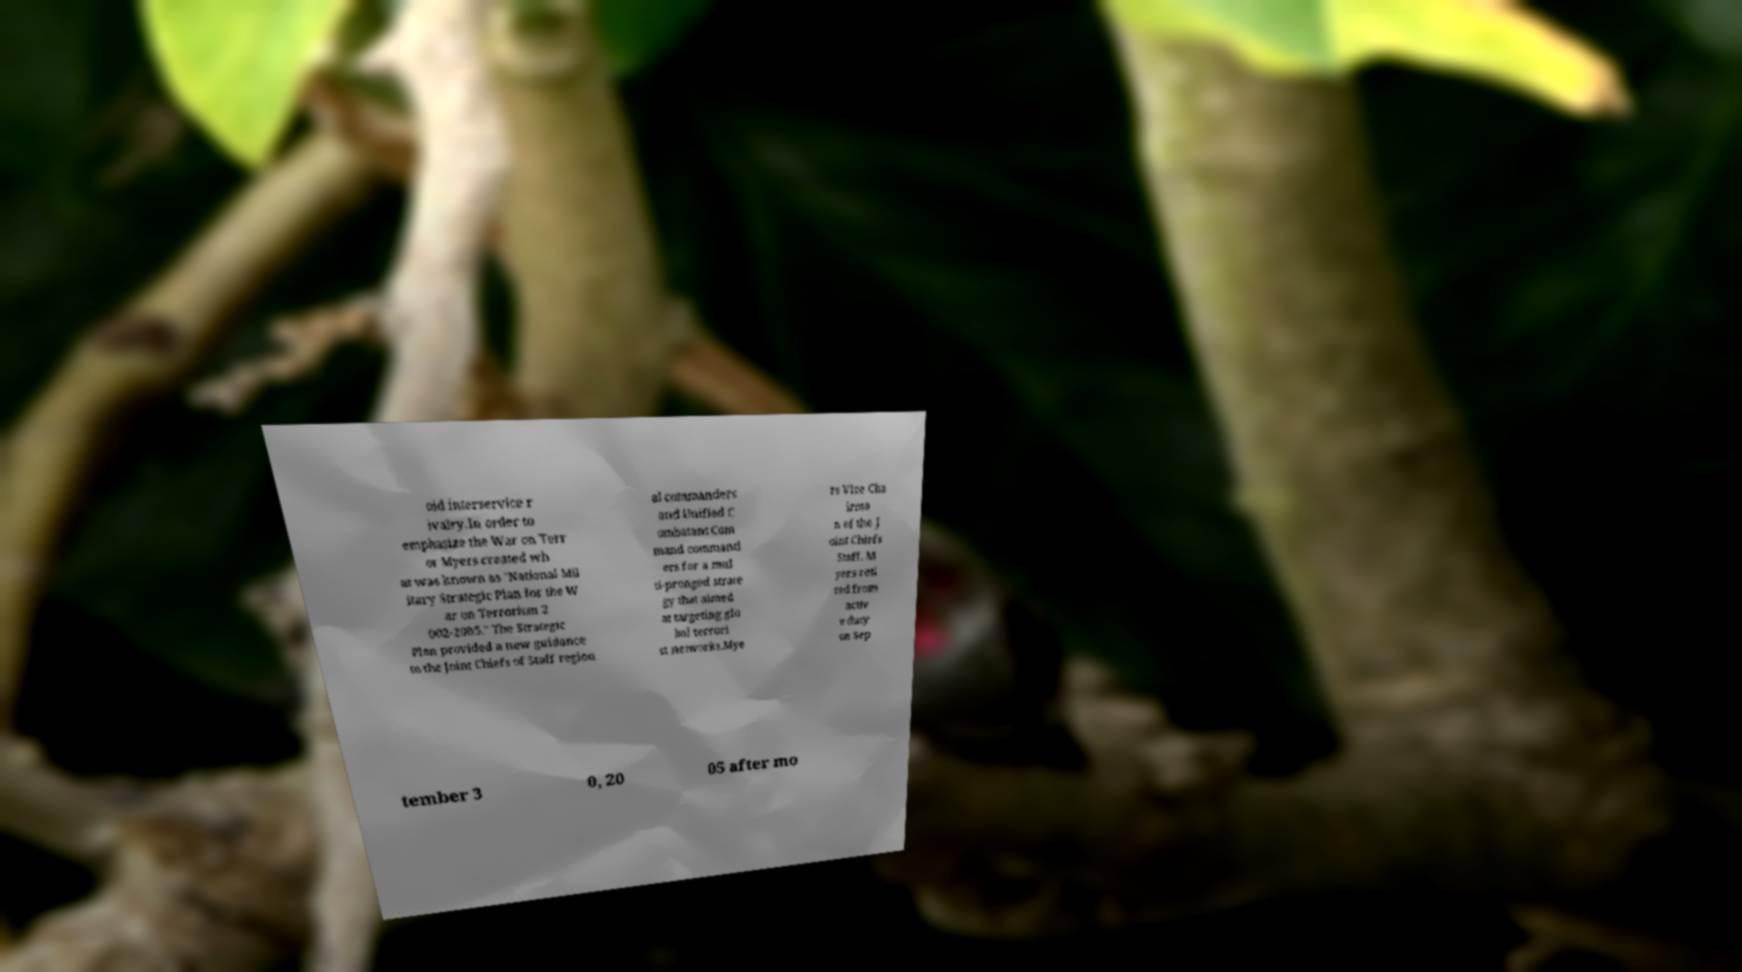Can you accurately transcribe the text from the provided image for me? oid interservice r ivalry.In order to emphasize the War on Terr or Myers created wh at was known as "National Mil itary Strategic Plan for the W ar on Terrorism 2 002-2005." The Strategic Plan provided a new guidance to the Joint Chiefs of Staff region al commanders and Unified C ombatant Com mand command ers for a mul ti-pronged strate gy that aimed at targeting glo bal terrori st networks.Mye rs Vice Cha irma n of the J oint Chiefs Staff. M yers reti red from activ e duty on Sep tember 3 0, 20 05 after mo 